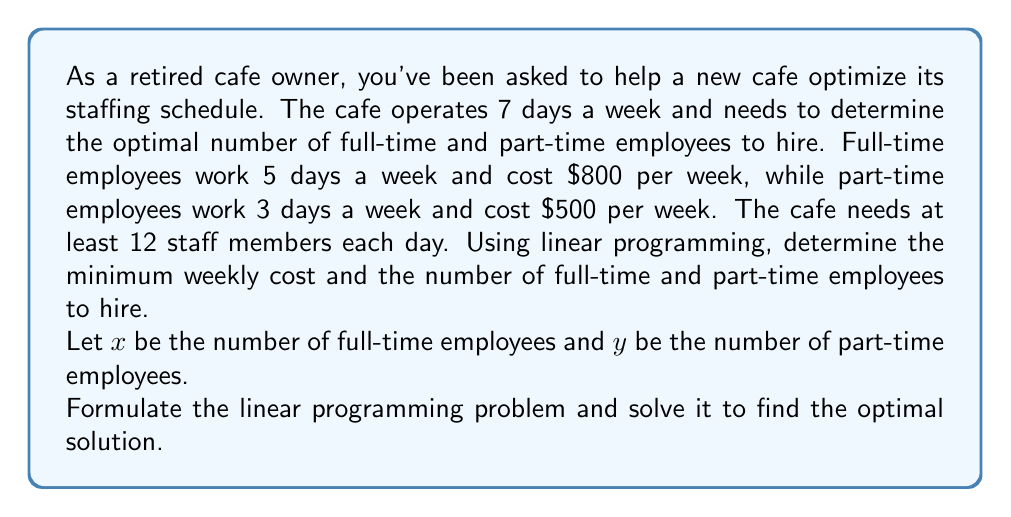Help me with this question. Let's approach this problem step-by-step using linear programming:

1. Define the objective function:
   We want to minimize the total weekly cost.
   $$\text{Minimize } Z = 800x + 500y$$

2. Define the constraints:
   a) Each day needs at least 12 staff members:
      $$5x + 3y \geq 84$$ (12 staff × 7 days = 84 total staff-days)
   b) Non-negativity constraints:
      $$x \geq 0, y \geq 0$$

3. Set up the linear programming problem:
   $$\text{Minimize } Z = 800x + 500y$$
   $$\text{Subject to:}$$
   $$5x + 3y \geq 84$$
   $$x \geq 0, y \geq 0$$

4. Solve using the graphical method:
   a) Plot the constraint: $5x + 3y = 84$
   b) Shade the feasible region (above the line)
   c) Plot the objective function lines

5. Find the optimal solution:
   The optimal solution will be at the corner point of the feasible region closest to the origin.
   Solving the equation:
   $$5x + 3y = 84$$
   $$x = 0: y = 28$$
   $$y = 0: x = 16.8$$

   The corner point is at the intersection of $x = 12$ and $y = 8$.

6. Calculate the minimum cost:
   $$Z = 800(12) + 500(8) = 9600 + 4000 = 13600$$

Therefore, the optimal solution is to hire 12 full-time employees and 8 part-time employees, with a minimum weekly cost of $13,600.
Answer: Optimal solution: 12 full-time employees and 8 part-time employees
Minimum weekly cost: $13,600 